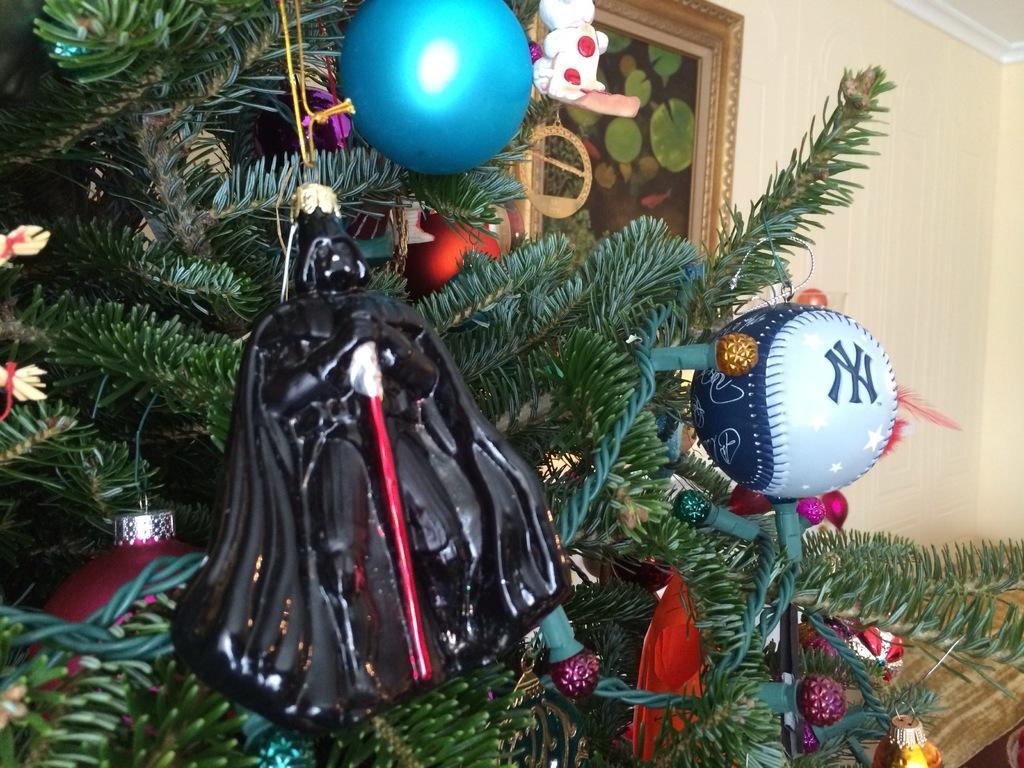Please provide a concise description of this image. In this image there is a Christmas tree, few balls, a window, few toys and the wall. 